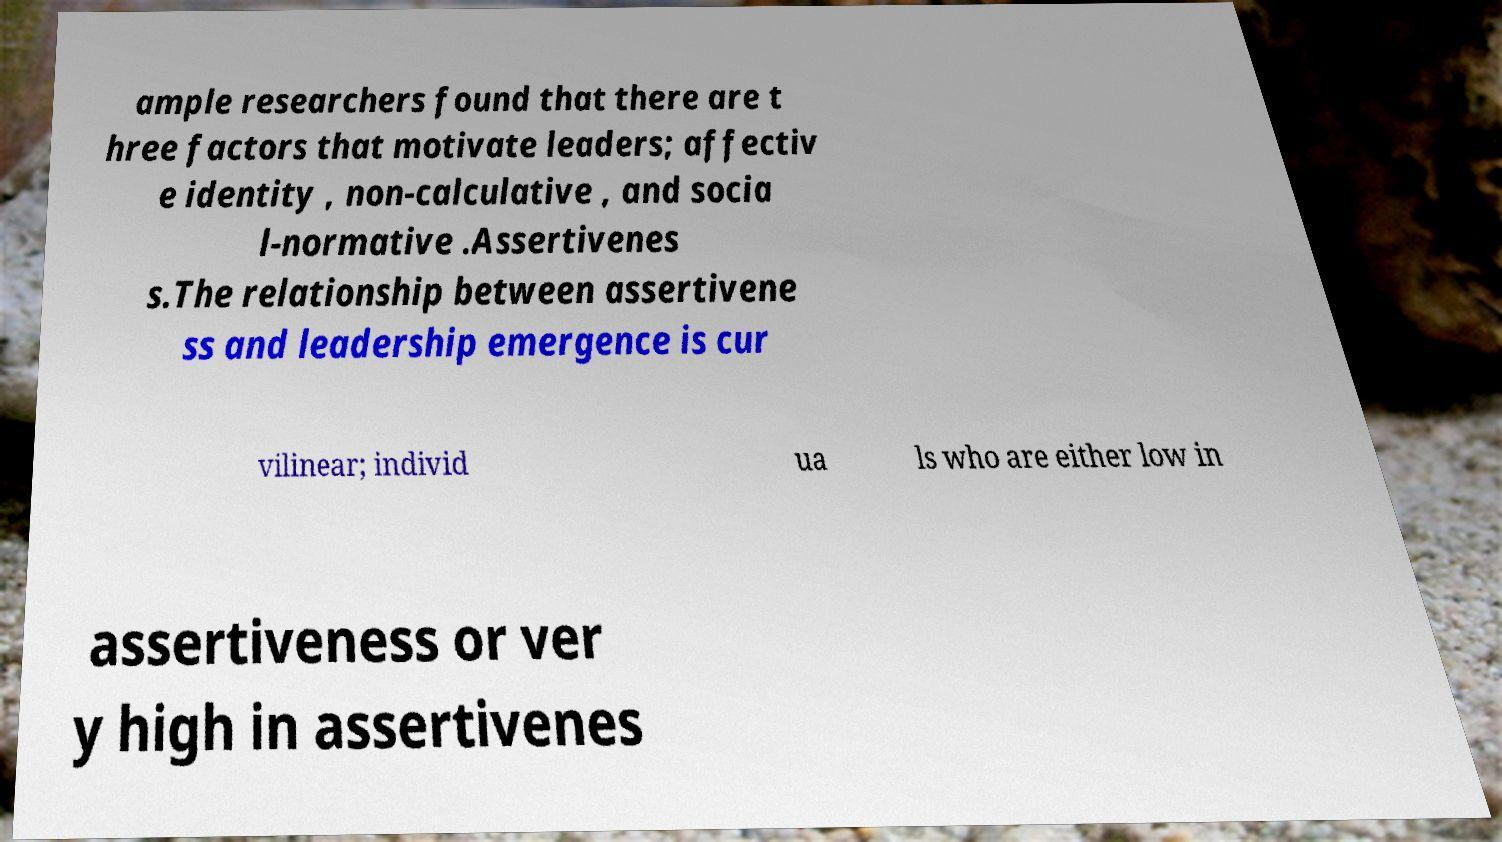Can you read and provide the text displayed in the image?This photo seems to have some interesting text. Can you extract and type it out for me? ample researchers found that there are t hree factors that motivate leaders; affectiv e identity , non-calculative , and socia l-normative .Assertivenes s.The relationship between assertivene ss and leadership emergence is cur vilinear; individ ua ls who are either low in assertiveness or ver y high in assertivenes 